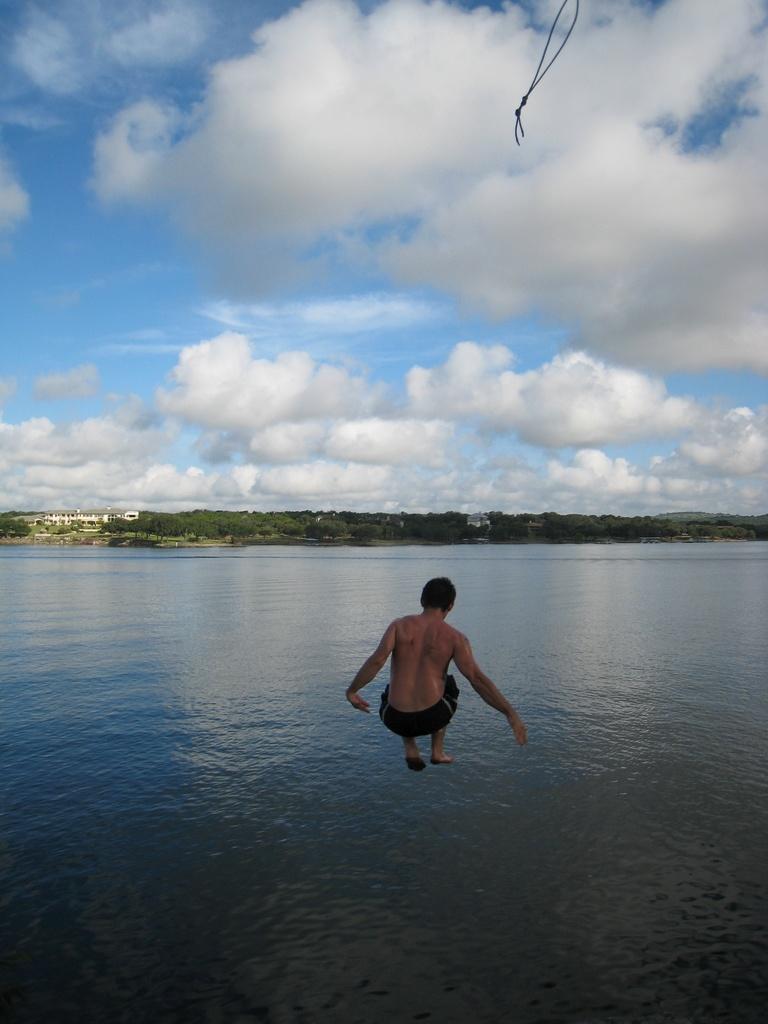Please provide a concise description of this image. In this image, the sky is blue in color and it is cloudy and the person is jumping into the water. 